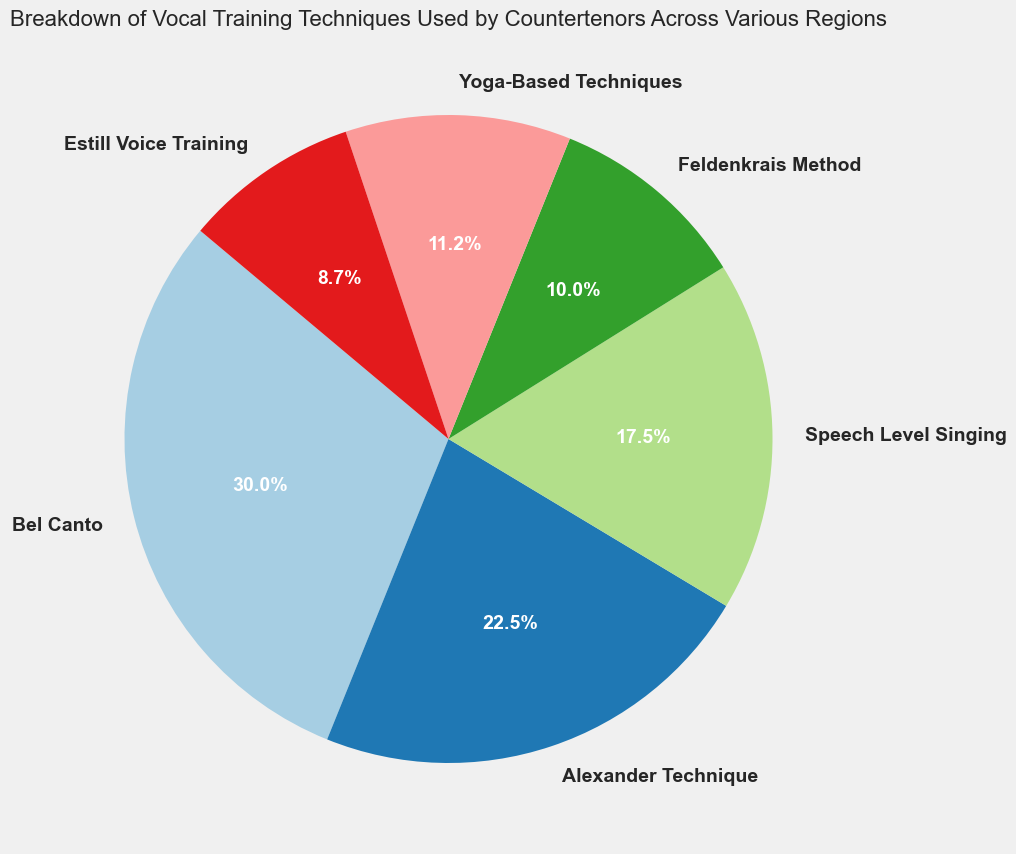Which technique has the highest usage across all regions? The pie chart shows the percentage breakdown of each vocal training technique across all regions. By looking at the largest segment, we can determine the technique with the highest usage. The biggest segment represents Bel Canto.
Answer: Bel Canto Which technique has the lowest usage across all regions? The pie chart indicates the percentage usage of each technique. The smallest segment corresponds to the technique with the lowest overall usage. The smallest segment represents Feldenkrais Method and Estill Voice Training equally.
Answer: Feldenkrais Method and Estill Voice Training How much higher is the usage of Bel Canto compared to Speech Level Singing? To determine the difference, compare the percentages of the Bel Canto and Speech Level Singing pie segments. Bel Canto has the highest percentage at 35%, while Speech Level Singing has 15%. The difference is 35% - 15% = 20%.
Answer: 20% What is the combined usage of Yoga-Based Techniques and Estill Voice Training across all regions? The pie chart shows individual percentages for each technique. Adding the percentages for Yoga-Based Techniques (10%) and Estill Voice Training (10%) gives the combined usage: 10% + 10% = 20%.
Answer: 20% Is the usage of Alexander Technique higher than Feldenkrais Method? The pie chart percentages indicate the usage for each technique. Alexander Technique is shown at 20%, while Feldenkrais Method is at 10%. Since 20% (Alexander Technique) is greater than 10% (Feldenkrais Method), Alexander Technique has higher usage.
Answer: Yes Which two techniques have equal usage across all regions? The pie chart shows percentage breakdowns for each technique. Two pairs have equal usage: Yoga-Based Techniques and Estill Voice Training both at 10%, and Alexander Technique and Feldenkrais Method both at 10%. Therefore the correct pairs are Yoga-Based Techniques and Estill Voice Training.
Answer: Yoga-Based Techniques and Estill Voice Training Which technique is used less: Speech Level Singing or Feldenkrais Method? By comparing the pie chart segments for these two techniques, we see that Speech Level Singing is at 15% and Feldenkrais Method is at 10%. Feldenkrais Method is used less.
Answer: Feldenkrais Method What is the total usage percentage of techniques other than Bel Canto? The total percentage for all techniques is 100%. Subtracting the percentage for Bel Canto (35%) from 100%, we get the total for other techniques: 100% - 35% = 65%.
Answer: 65% What is the average usage percentage of Alexander Technique, Feldenkrais Method, and Yoga-Based Techniques? The percentages for these three techniques are Alexander Technique (20%), Feldenkrais Method (10%), and Yoga-Based Techniques (10%). Summing them up gives 20% + 10% + 10% = 40%. Dividing by 3, we get the average usage: 40% / 3 ≈ 13.3%.
Answer: 13.3% 